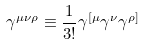Convert formula to latex. <formula><loc_0><loc_0><loc_500><loc_500>\gamma ^ { \mu \nu \rho } \equiv \frac { 1 } { 3 ! } \gamma ^ { [ \mu } \gamma ^ { \nu } \gamma ^ { \rho ] }</formula> 